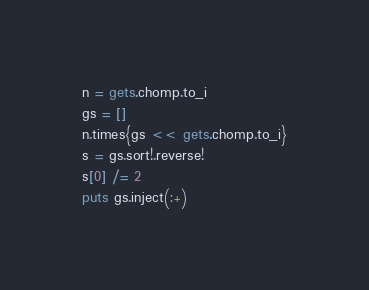Convert code to text. <code><loc_0><loc_0><loc_500><loc_500><_Ruby_>n = gets.chomp.to_i
gs = []
n.times{gs << gets.chomp.to_i}
s = gs.sort!.reverse!
s[0] /= 2
puts gs.inject(:+)</code> 